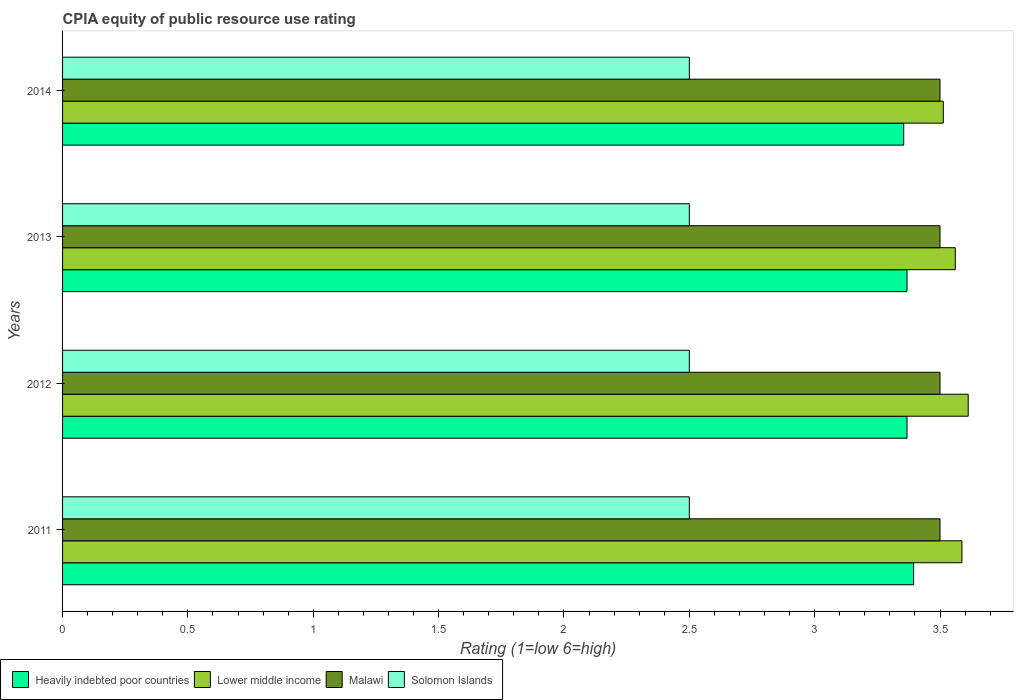How many different coloured bars are there?
Your answer should be compact. 4. How many bars are there on the 2nd tick from the top?
Your answer should be very brief. 4. How many bars are there on the 2nd tick from the bottom?
Your response must be concise. 4. In how many cases, is the number of bars for a given year not equal to the number of legend labels?
Provide a succinct answer. 0. Across all years, what is the minimum CPIA rating in Solomon Islands?
Provide a short and direct response. 2.5. What is the total CPIA rating in Lower middle income in the graph?
Your response must be concise. 14.27. What is the difference between the CPIA rating in Solomon Islands in 2011 and the CPIA rating in Malawi in 2012?
Give a very brief answer. -1. What is the average CPIA rating in Solomon Islands per year?
Make the answer very short. 2.5. In the year 2011, what is the difference between the CPIA rating in Lower middle income and CPIA rating in Solomon Islands?
Provide a short and direct response. 1.09. What is the difference between the highest and the second highest CPIA rating in Lower middle income?
Keep it short and to the point. 0.02. What is the difference between the highest and the lowest CPIA rating in Heavily indebted poor countries?
Your answer should be very brief. 0.04. In how many years, is the CPIA rating in Heavily indebted poor countries greater than the average CPIA rating in Heavily indebted poor countries taken over all years?
Provide a succinct answer. 1. Is the sum of the CPIA rating in Heavily indebted poor countries in 2011 and 2013 greater than the maximum CPIA rating in Solomon Islands across all years?
Ensure brevity in your answer.  Yes. What does the 4th bar from the top in 2011 represents?
Provide a short and direct response. Heavily indebted poor countries. What does the 4th bar from the bottom in 2011 represents?
Offer a very short reply. Solomon Islands. Does the graph contain any zero values?
Make the answer very short. No. Does the graph contain grids?
Provide a short and direct response. No. Where does the legend appear in the graph?
Offer a very short reply. Bottom left. How are the legend labels stacked?
Offer a very short reply. Horizontal. What is the title of the graph?
Your answer should be compact. CPIA equity of public resource use rating. What is the label or title of the Y-axis?
Ensure brevity in your answer.  Years. What is the Rating (1=low 6=high) in Heavily indebted poor countries in 2011?
Make the answer very short. 3.39. What is the Rating (1=low 6=high) in Lower middle income in 2011?
Your answer should be compact. 3.59. What is the Rating (1=low 6=high) in Solomon Islands in 2011?
Make the answer very short. 2.5. What is the Rating (1=low 6=high) of Heavily indebted poor countries in 2012?
Your answer should be very brief. 3.37. What is the Rating (1=low 6=high) of Lower middle income in 2012?
Ensure brevity in your answer.  3.61. What is the Rating (1=low 6=high) of Malawi in 2012?
Make the answer very short. 3.5. What is the Rating (1=low 6=high) of Solomon Islands in 2012?
Your response must be concise. 2.5. What is the Rating (1=low 6=high) in Heavily indebted poor countries in 2013?
Ensure brevity in your answer.  3.37. What is the Rating (1=low 6=high) of Lower middle income in 2013?
Make the answer very short. 3.56. What is the Rating (1=low 6=high) of Heavily indebted poor countries in 2014?
Your answer should be very brief. 3.36. What is the Rating (1=low 6=high) in Lower middle income in 2014?
Ensure brevity in your answer.  3.51. What is the Rating (1=low 6=high) in Malawi in 2014?
Make the answer very short. 3.5. Across all years, what is the maximum Rating (1=low 6=high) in Heavily indebted poor countries?
Give a very brief answer. 3.39. Across all years, what is the maximum Rating (1=low 6=high) in Lower middle income?
Provide a succinct answer. 3.61. Across all years, what is the maximum Rating (1=low 6=high) in Malawi?
Offer a very short reply. 3.5. Across all years, what is the minimum Rating (1=low 6=high) in Heavily indebted poor countries?
Your answer should be very brief. 3.36. Across all years, what is the minimum Rating (1=low 6=high) of Lower middle income?
Offer a terse response. 3.51. What is the total Rating (1=low 6=high) of Heavily indebted poor countries in the graph?
Ensure brevity in your answer.  13.49. What is the total Rating (1=low 6=high) of Lower middle income in the graph?
Your answer should be very brief. 14.27. What is the difference between the Rating (1=low 6=high) in Heavily indebted poor countries in 2011 and that in 2012?
Offer a very short reply. 0.03. What is the difference between the Rating (1=low 6=high) in Lower middle income in 2011 and that in 2012?
Your answer should be compact. -0.03. What is the difference between the Rating (1=low 6=high) of Heavily indebted poor countries in 2011 and that in 2013?
Give a very brief answer. 0.03. What is the difference between the Rating (1=low 6=high) in Lower middle income in 2011 and that in 2013?
Offer a very short reply. 0.03. What is the difference between the Rating (1=low 6=high) of Solomon Islands in 2011 and that in 2013?
Ensure brevity in your answer.  0. What is the difference between the Rating (1=low 6=high) in Heavily indebted poor countries in 2011 and that in 2014?
Keep it short and to the point. 0.04. What is the difference between the Rating (1=low 6=high) of Lower middle income in 2011 and that in 2014?
Offer a very short reply. 0.07. What is the difference between the Rating (1=low 6=high) in Malawi in 2011 and that in 2014?
Ensure brevity in your answer.  0. What is the difference between the Rating (1=low 6=high) of Solomon Islands in 2011 and that in 2014?
Your response must be concise. 0. What is the difference between the Rating (1=low 6=high) of Lower middle income in 2012 and that in 2013?
Your answer should be compact. 0.05. What is the difference between the Rating (1=low 6=high) of Malawi in 2012 and that in 2013?
Provide a short and direct response. 0. What is the difference between the Rating (1=low 6=high) of Heavily indebted poor countries in 2012 and that in 2014?
Give a very brief answer. 0.01. What is the difference between the Rating (1=low 6=high) in Lower middle income in 2012 and that in 2014?
Offer a very short reply. 0.1. What is the difference between the Rating (1=low 6=high) in Malawi in 2012 and that in 2014?
Provide a succinct answer. 0. What is the difference between the Rating (1=low 6=high) of Heavily indebted poor countries in 2013 and that in 2014?
Provide a short and direct response. 0.01. What is the difference between the Rating (1=low 6=high) in Lower middle income in 2013 and that in 2014?
Provide a succinct answer. 0.05. What is the difference between the Rating (1=low 6=high) in Heavily indebted poor countries in 2011 and the Rating (1=low 6=high) in Lower middle income in 2012?
Your response must be concise. -0.22. What is the difference between the Rating (1=low 6=high) in Heavily indebted poor countries in 2011 and the Rating (1=low 6=high) in Malawi in 2012?
Your answer should be very brief. -0.11. What is the difference between the Rating (1=low 6=high) of Heavily indebted poor countries in 2011 and the Rating (1=low 6=high) of Solomon Islands in 2012?
Offer a very short reply. 0.89. What is the difference between the Rating (1=low 6=high) in Lower middle income in 2011 and the Rating (1=low 6=high) in Malawi in 2012?
Provide a succinct answer. 0.09. What is the difference between the Rating (1=low 6=high) in Lower middle income in 2011 and the Rating (1=low 6=high) in Solomon Islands in 2012?
Provide a short and direct response. 1.09. What is the difference between the Rating (1=low 6=high) of Heavily indebted poor countries in 2011 and the Rating (1=low 6=high) of Lower middle income in 2013?
Make the answer very short. -0.17. What is the difference between the Rating (1=low 6=high) of Heavily indebted poor countries in 2011 and the Rating (1=low 6=high) of Malawi in 2013?
Your answer should be compact. -0.11. What is the difference between the Rating (1=low 6=high) of Heavily indebted poor countries in 2011 and the Rating (1=low 6=high) of Solomon Islands in 2013?
Ensure brevity in your answer.  0.89. What is the difference between the Rating (1=low 6=high) in Lower middle income in 2011 and the Rating (1=low 6=high) in Malawi in 2013?
Your answer should be very brief. 0.09. What is the difference between the Rating (1=low 6=high) in Lower middle income in 2011 and the Rating (1=low 6=high) in Solomon Islands in 2013?
Your answer should be very brief. 1.09. What is the difference between the Rating (1=low 6=high) of Malawi in 2011 and the Rating (1=low 6=high) of Solomon Islands in 2013?
Ensure brevity in your answer.  1. What is the difference between the Rating (1=low 6=high) of Heavily indebted poor countries in 2011 and the Rating (1=low 6=high) of Lower middle income in 2014?
Keep it short and to the point. -0.12. What is the difference between the Rating (1=low 6=high) of Heavily indebted poor countries in 2011 and the Rating (1=low 6=high) of Malawi in 2014?
Keep it short and to the point. -0.11. What is the difference between the Rating (1=low 6=high) of Heavily indebted poor countries in 2011 and the Rating (1=low 6=high) of Solomon Islands in 2014?
Make the answer very short. 0.89. What is the difference between the Rating (1=low 6=high) in Lower middle income in 2011 and the Rating (1=low 6=high) in Malawi in 2014?
Offer a very short reply. 0.09. What is the difference between the Rating (1=low 6=high) in Lower middle income in 2011 and the Rating (1=low 6=high) in Solomon Islands in 2014?
Offer a very short reply. 1.09. What is the difference between the Rating (1=low 6=high) in Heavily indebted poor countries in 2012 and the Rating (1=low 6=high) in Lower middle income in 2013?
Offer a terse response. -0.19. What is the difference between the Rating (1=low 6=high) of Heavily indebted poor countries in 2012 and the Rating (1=low 6=high) of Malawi in 2013?
Your response must be concise. -0.13. What is the difference between the Rating (1=low 6=high) of Heavily indebted poor countries in 2012 and the Rating (1=low 6=high) of Solomon Islands in 2013?
Give a very brief answer. 0.87. What is the difference between the Rating (1=low 6=high) of Lower middle income in 2012 and the Rating (1=low 6=high) of Malawi in 2013?
Your answer should be very brief. 0.11. What is the difference between the Rating (1=low 6=high) of Lower middle income in 2012 and the Rating (1=low 6=high) of Solomon Islands in 2013?
Give a very brief answer. 1.11. What is the difference between the Rating (1=low 6=high) in Heavily indebted poor countries in 2012 and the Rating (1=low 6=high) in Lower middle income in 2014?
Your answer should be compact. -0.14. What is the difference between the Rating (1=low 6=high) in Heavily indebted poor countries in 2012 and the Rating (1=low 6=high) in Malawi in 2014?
Make the answer very short. -0.13. What is the difference between the Rating (1=low 6=high) in Heavily indebted poor countries in 2012 and the Rating (1=low 6=high) in Solomon Islands in 2014?
Make the answer very short. 0.87. What is the difference between the Rating (1=low 6=high) of Lower middle income in 2012 and the Rating (1=low 6=high) of Malawi in 2014?
Provide a short and direct response. 0.11. What is the difference between the Rating (1=low 6=high) of Lower middle income in 2012 and the Rating (1=low 6=high) of Solomon Islands in 2014?
Your answer should be compact. 1.11. What is the difference between the Rating (1=low 6=high) in Heavily indebted poor countries in 2013 and the Rating (1=low 6=high) in Lower middle income in 2014?
Make the answer very short. -0.14. What is the difference between the Rating (1=low 6=high) in Heavily indebted poor countries in 2013 and the Rating (1=low 6=high) in Malawi in 2014?
Your response must be concise. -0.13. What is the difference between the Rating (1=low 6=high) in Heavily indebted poor countries in 2013 and the Rating (1=low 6=high) in Solomon Islands in 2014?
Ensure brevity in your answer.  0.87. What is the difference between the Rating (1=low 6=high) of Lower middle income in 2013 and the Rating (1=low 6=high) of Malawi in 2014?
Provide a short and direct response. 0.06. What is the difference between the Rating (1=low 6=high) in Lower middle income in 2013 and the Rating (1=low 6=high) in Solomon Islands in 2014?
Provide a short and direct response. 1.06. What is the difference between the Rating (1=low 6=high) in Malawi in 2013 and the Rating (1=low 6=high) in Solomon Islands in 2014?
Give a very brief answer. 1. What is the average Rating (1=low 6=high) of Heavily indebted poor countries per year?
Offer a terse response. 3.37. What is the average Rating (1=low 6=high) of Lower middle income per year?
Your response must be concise. 3.57. In the year 2011, what is the difference between the Rating (1=low 6=high) of Heavily indebted poor countries and Rating (1=low 6=high) of Lower middle income?
Make the answer very short. -0.19. In the year 2011, what is the difference between the Rating (1=low 6=high) of Heavily indebted poor countries and Rating (1=low 6=high) of Malawi?
Provide a short and direct response. -0.11. In the year 2011, what is the difference between the Rating (1=low 6=high) of Heavily indebted poor countries and Rating (1=low 6=high) of Solomon Islands?
Keep it short and to the point. 0.89. In the year 2011, what is the difference between the Rating (1=low 6=high) of Lower middle income and Rating (1=low 6=high) of Malawi?
Offer a terse response. 0.09. In the year 2011, what is the difference between the Rating (1=low 6=high) of Lower middle income and Rating (1=low 6=high) of Solomon Islands?
Provide a short and direct response. 1.09. In the year 2011, what is the difference between the Rating (1=low 6=high) of Malawi and Rating (1=low 6=high) of Solomon Islands?
Your response must be concise. 1. In the year 2012, what is the difference between the Rating (1=low 6=high) in Heavily indebted poor countries and Rating (1=low 6=high) in Lower middle income?
Provide a short and direct response. -0.24. In the year 2012, what is the difference between the Rating (1=low 6=high) in Heavily indebted poor countries and Rating (1=low 6=high) in Malawi?
Provide a short and direct response. -0.13. In the year 2012, what is the difference between the Rating (1=low 6=high) in Heavily indebted poor countries and Rating (1=low 6=high) in Solomon Islands?
Your response must be concise. 0.87. In the year 2012, what is the difference between the Rating (1=low 6=high) in Lower middle income and Rating (1=low 6=high) in Malawi?
Provide a succinct answer. 0.11. In the year 2012, what is the difference between the Rating (1=low 6=high) in Lower middle income and Rating (1=low 6=high) in Solomon Islands?
Your response must be concise. 1.11. In the year 2013, what is the difference between the Rating (1=low 6=high) in Heavily indebted poor countries and Rating (1=low 6=high) in Lower middle income?
Your answer should be very brief. -0.19. In the year 2013, what is the difference between the Rating (1=low 6=high) in Heavily indebted poor countries and Rating (1=low 6=high) in Malawi?
Keep it short and to the point. -0.13. In the year 2013, what is the difference between the Rating (1=low 6=high) in Heavily indebted poor countries and Rating (1=low 6=high) in Solomon Islands?
Offer a very short reply. 0.87. In the year 2013, what is the difference between the Rating (1=low 6=high) in Lower middle income and Rating (1=low 6=high) in Malawi?
Provide a succinct answer. 0.06. In the year 2013, what is the difference between the Rating (1=low 6=high) of Lower middle income and Rating (1=low 6=high) of Solomon Islands?
Give a very brief answer. 1.06. In the year 2013, what is the difference between the Rating (1=low 6=high) of Malawi and Rating (1=low 6=high) of Solomon Islands?
Your response must be concise. 1. In the year 2014, what is the difference between the Rating (1=low 6=high) in Heavily indebted poor countries and Rating (1=low 6=high) in Lower middle income?
Provide a succinct answer. -0.16. In the year 2014, what is the difference between the Rating (1=low 6=high) in Heavily indebted poor countries and Rating (1=low 6=high) in Malawi?
Offer a terse response. -0.14. In the year 2014, what is the difference between the Rating (1=low 6=high) of Heavily indebted poor countries and Rating (1=low 6=high) of Solomon Islands?
Offer a terse response. 0.86. In the year 2014, what is the difference between the Rating (1=low 6=high) of Lower middle income and Rating (1=low 6=high) of Malawi?
Your answer should be compact. 0.01. In the year 2014, what is the difference between the Rating (1=low 6=high) in Lower middle income and Rating (1=low 6=high) in Solomon Islands?
Offer a very short reply. 1.01. In the year 2014, what is the difference between the Rating (1=low 6=high) of Malawi and Rating (1=low 6=high) of Solomon Islands?
Make the answer very short. 1. What is the ratio of the Rating (1=low 6=high) of Malawi in 2011 to that in 2012?
Give a very brief answer. 1. What is the ratio of the Rating (1=low 6=high) in Heavily indebted poor countries in 2011 to that in 2013?
Offer a very short reply. 1.01. What is the ratio of the Rating (1=low 6=high) in Lower middle income in 2011 to that in 2013?
Your response must be concise. 1.01. What is the ratio of the Rating (1=low 6=high) in Solomon Islands in 2011 to that in 2013?
Your response must be concise. 1. What is the ratio of the Rating (1=low 6=high) of Heavily indebted poor countries in 2011 to that in 2014?
Ensure brevity in your answer.  1.01. What is the ratio of the Rating (1=low 6=high) of Lower middle income in 2011 to that in 2014?
Your response must be concise. 1.02. What is the ratio of the Rating (1=low 6=high) of Heavily indebted poor countries in 2012 to that in 2013?
Give a very brief answer. 1. What is the ratio of the Rating (1=low 6=high) in Lower middle income in 2012 to that in 2013?
Ensure brevity in your answer.  1.01. What is the ratio of the Rating (1=low 6=high) in Malawi in 2012 to that in 2013?
Your answer should be compact. 1. What is the ratio of the Rating (1=low 6=high) of Lower middle income in 2012 to that in 2014?
Give a very brief answer. 1.03. What is the ratio of the Rating (1=low 6=high) in Malawi in 2012 to that in 2014?
Give a very brief answer. 1. What is the ratio of the Rating (1=low 6=high) of Solomon Islands in 2012 to that in 2014?
Keep it short and to the point. 1. What is the ratio of the Rating (1=low 6=high) in Lower middle income in 2013 to that in 2014?
Keep it short and to the point. 1.01. What is the ratio of the Rating (1=low 6=high) of Malawi in 2013 to that in 2014?
Your answer should be very brief. 1. What is the ratio of the Rating (1=low 6=high) of Solomon Islands in 2013 to that in 2014?
Give a very brief answer. 1. What is the difference between the highest and the second highest Rating (1=low 6=high) of Heavily indebted poor countries?
Your response must be concise. 0.03. What is the difference between the highest and the second highest Rating (1=low 6=high) of Lower middle income?
Keep it short and to the point. 0.03. What is the difference between the highest and the second highest Rating (1=low 6=high) in Solomon Islands?
Your response must be concise. 0. What is the difference between the highest and the lowest Rating (1=low 6=high) of Heavily indebted poor countries?
Keep it short and to the point. 0.04. What is the difference between the highest and the lowest Rating (1=low 6=high) in Lower middle income?
Offer a very short reply. 0.1. What is the difference between the highest and the lowest Rating (1=low 6=high) of Malawi?
Provide a short and direct response. 0. What is the difference between the highest and the lowest Rating (1=low 6=high) in Solomon Islands?
Your answer should be compact. 0. 